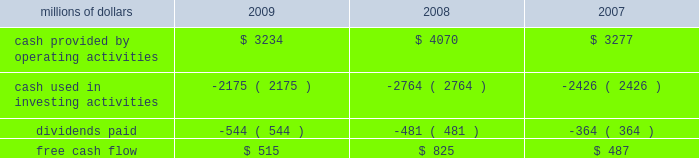2022 asset utilization 2013 in response to economic conditions and lower revenue in 2009 , we implemented productivity initiatives to improve efficiency and reduce costs , in addition to adjusting our resources to reflect lower demand .
Although varying throughout the year , our resource reductions included removing from service approximately 26% ( 26 % ) of our road locomotives and 18% ( 18 % ) of our freight car inventory by year end .
We also reduced shift levels at most rail facilities and closed or significantly reduced operations in 30 of our 114 principal rail yards .
These demand-driven resource adjustments and our productivity initiatives combined to reduce our workforce by 10% ( 10 % ) .
2022 fuel prices 2013 as the economy worsened during the third and fourth quarters of 2008 , fuel prices dropped dramatically , reaching $ 33.87 per barrel in december 2008 , a near five-year low .
Throughout 2009 , crude oil prices generally increased , ending the year around $ 80 per barrel .
Overall , our average fuel price decreased by 44% ( 44 % ) in 2009 , reducing operating expenses by $ 1.3 billion compared to 2008 .
We also reduced our consumption rate by 4% ( 4 % ) during the year , saving approximately 40 million gallons of fuel .
The use of newer , more fuel efficient locomotives ; increased use of distributed locomotive power ; fuel conservation programs ; and improved network operations and asset utilization all contributed to this improvement .
2022 free cash flow 2013 cash generated by operating activities totaled $ 3.2 billion , yielding free cash flow of $ 515 million in 2009 .
Free cash flow is defined as cash provided by operating activities , less cash used in investing activities and dividends paid .
Free cash flow is not considered a financial measure under accounting principles generally accepted in the united states ( gaap ) by sec regulation g and item 10 of sec regulation s-k .
We believe free cash flow is important in evaluating our financial performance and measures our ability to generate cash without additional external financings .
Free cash flow should be considered in addition to , rather than as a substitute for , cash provided by operating activities .
The table reconciles cash provided by operating activities ( gaap measure ) to free cash flow ( non-gaap measure ) : millions of dollars 2009 2008 2007 .
2010 outlook 2022 safety 2013 operating a safe railroad benefits our employees , our customers , our shareholders , and the public .
We will continue using a multi-faceted approach to safety , utilizing technology , risk assessment , quality control , and training , and by engaging our employees .
We will continue implementing total safety culture ( tsc ) throughout our operations .
Tsc is designed to establish , maintain , reinforce , and promote safe practices among co-workers .
This process allows us to identify and implement best practices for employee and operational safety .
Reducing grade-crossing incidents is a critical aspect of our safety programs , and we will continue our efforts to maintain , upgrade , and close crossings ; install video cameras on locomotives ; and educate the public about crossing safety through our own programs , various industry programs , and other activities .
2022 transportation plan 2013 to build upon our success in recent years , we will continue evaluating traffic flows and network logistic patterns , which can be quite dynamic from year-to-year , to identify additional opportunities to simplify operations , remove network variability and improve network efficiency and asset utilization .
We plan to adjust manpower and our locomotive and rail car fleets to .
What was the percentage change in free cash flow from 2008 to 2009? 
Computations: ((515 - 825) / 825)
Answer: -0.37576. 